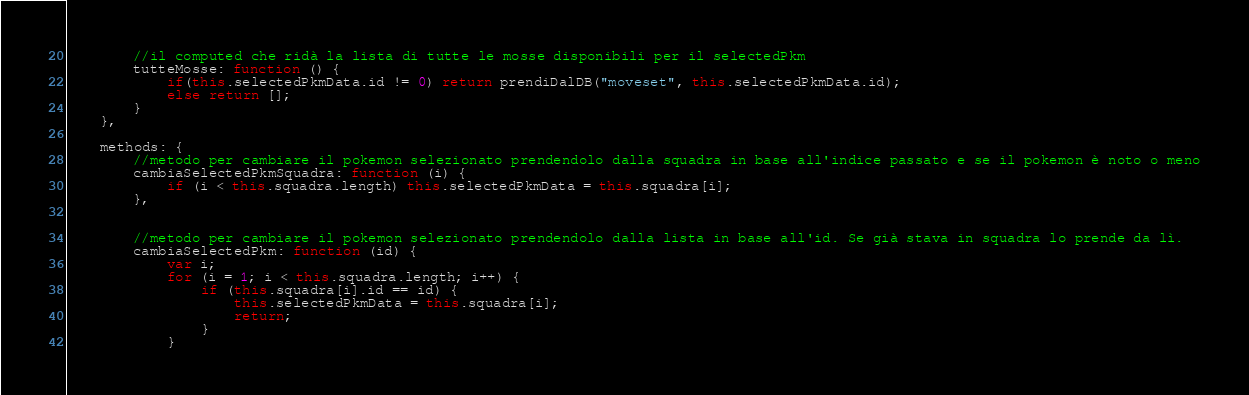<code> <loc_0><loc_0><loc_500><loc_500><_JavaScript_>
        //il computed che ridà la lista di tutte le mosse disponibili per il selectedPkm
        tutteMosse: function () {
            if(this.selectedPkmData.id != 0) return prendiDalDB("moveset", this.selectedPkmData.id);
            else return [];
        }
    },

    methods: {
        //metodo per cambiare il pokemon selezionato prendendolo dalla squadra in base all'indice passato e se il pokemon è noto o meno
        cambiaSelectedPkmSquadra: function (i) {
            if (i < this.squadra.length) this.selectedPkmData = this.squadra[i];
        },


        //metodo per cambiare il pokemon selezionato prendendolo dalla lista in base all'id. Se già stava in squadra lo prende da lì.
        cambiaSelectedPkm: function (id) {
            var i;
            for (i = 1; i < this.squadra.length; i++) {
                if (this.squadra[i].id == id) {
                    this.selectedPkmData = this.squadra[i];
                    return;
                }
            }
</code> 